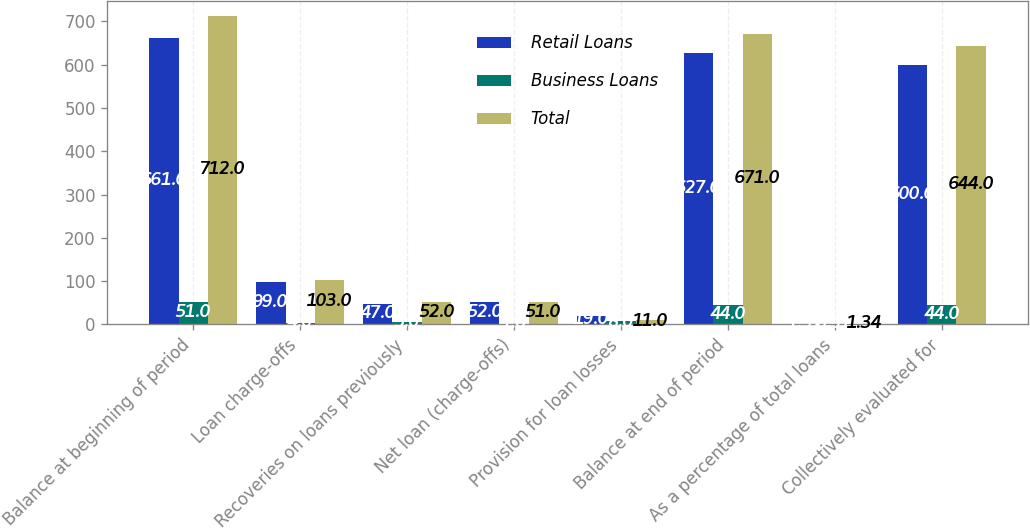Convert chart. <chart><loc_0><loc_0><loc_500><loc_500><stacked_bar_chart><ecel><fcel>Balance at beginning of period<fcel>Loan charge-offs<fcel>Recoveries on loans previously<fcel>Net loan (charge-offs)<fcel>Provision for loan losses<fcel>Balance at end of period<fcel>As a percentage of total loans<fcel>Collectively evaluated for<nl><fcel>Retail Loans<fcel>661<fcel>99<fcel>47<fcel>52<fcel>19<fcel>627<fcel>1.37<fcel>600<nl><fcel>Business Loans<fcel>51<fcel>4<fcel>5<fcel>1<fcel>8<fcel>44<fcel>0.97<fcel>44<nl><fcel>Total<fcel>712<fcel>103<fcel>52<fcel>51<fcel>11<fcel>671<fcel>1.34<fcel>644<nl></chart> 